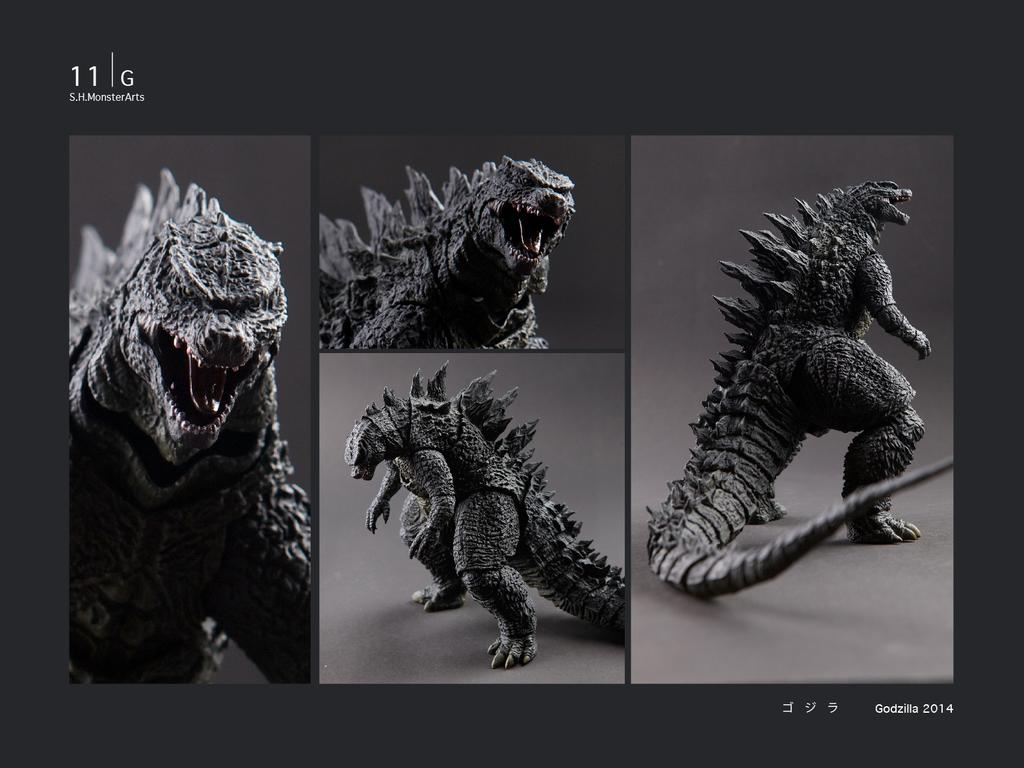What is the main subject of the image? The main subject of the image is a collage of an animal. Can you describe any text present in the image? Yes, there is text at the top and bottom of the image. What type of toy can be seen tied in a knot in the image? There is no toy or knot present in the image; it is a collage of an animal with text at the top and bottom. 